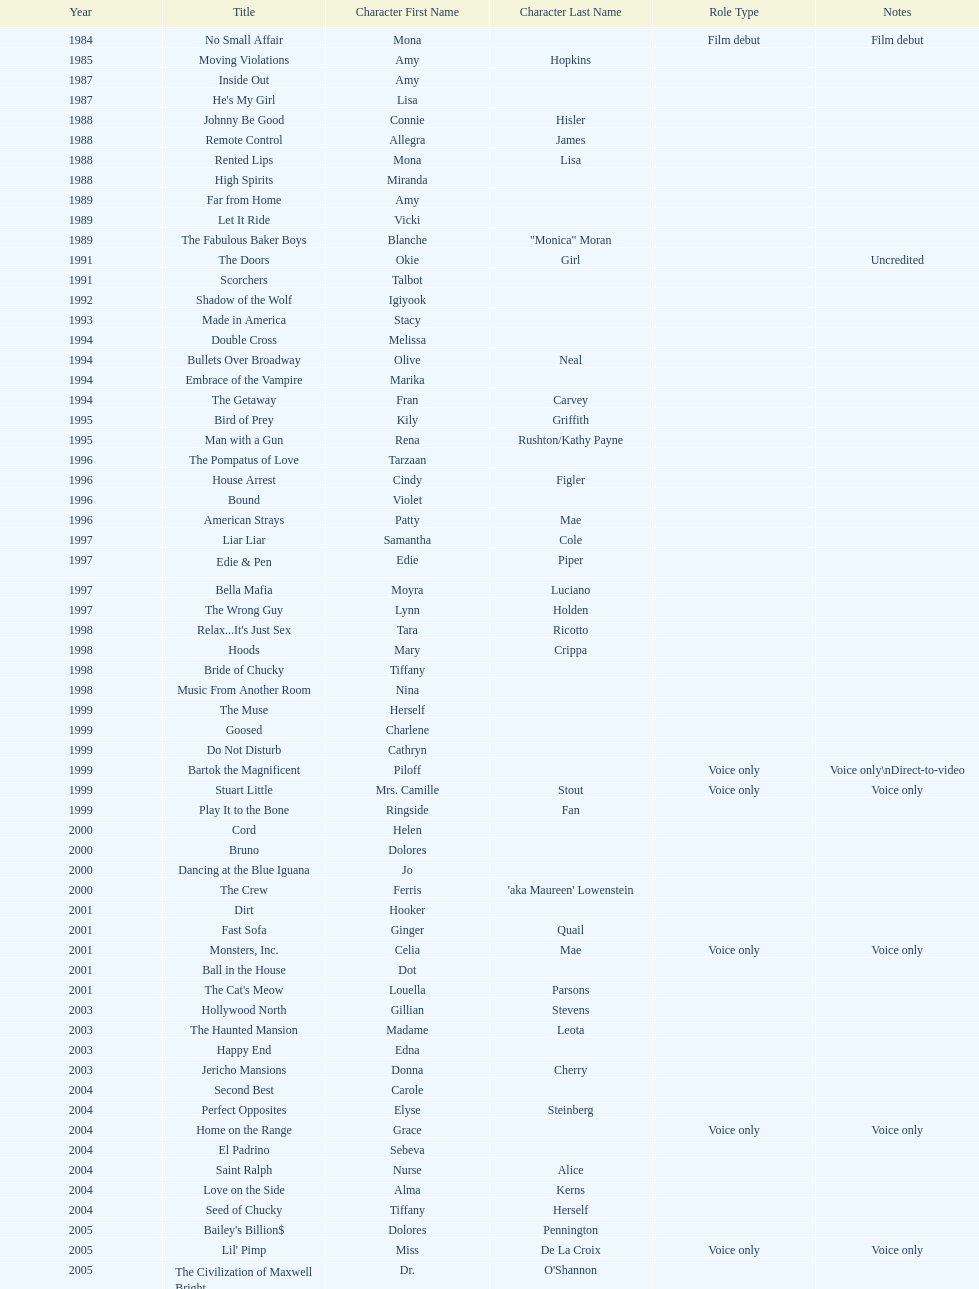Which film has their role under igiyook? Shadow of the Wolf. 